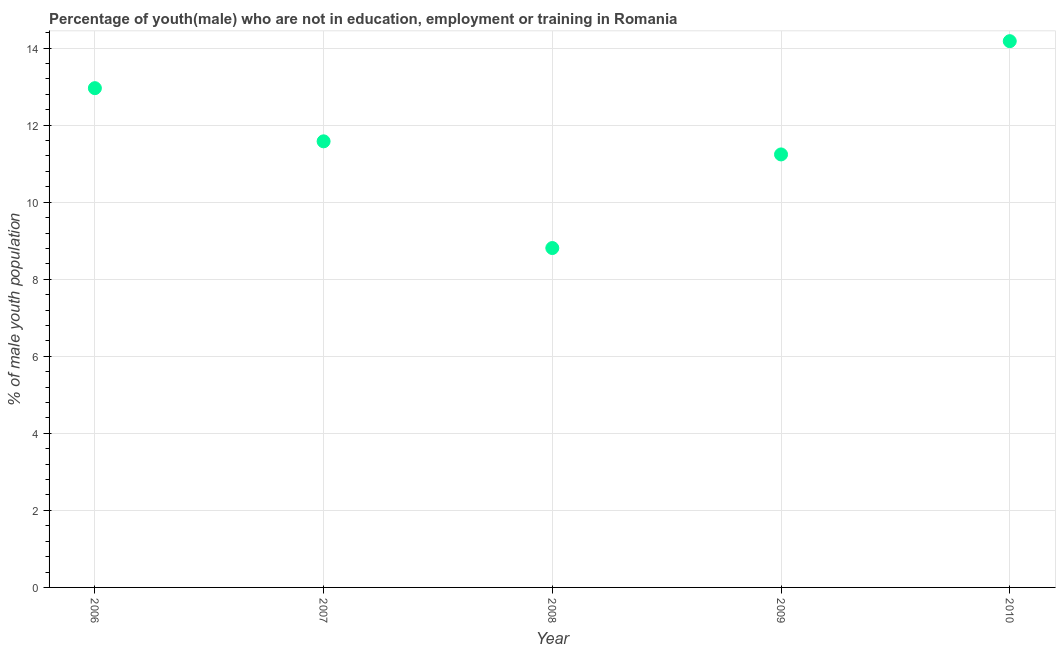What is the unemployed male youth population in 2007?
Your response must be concise. 11.58. Across all years, what is the maximum unemployed male youth population?
Give a very brief answer. 14.18. Across all years, what is the minimum unemployed male youth population?
Your answer should be very brief. 8.81. In which year was the unemployed male youth population maximum?
Make the answer very short. 2010. What is the sum of the unemployed male youth population?
Make the answer very short. 58.77. What is the difference between the unemployed male youth population in 2006 and 2010?
Your answer should be compact. -1.22. What is the average unemployed male youth population per year?
Keep it short and to the point. 11.75. What is the median unemployed male youth population?
Give a very brief answer. 11.58. Do a majority of the years between 2006 and 2008 (inclusive) have unemployed male youth population greater than 0.4 %?
Your answer should be compact. Yes. What is the ratio of the unemployed male youth population in 2006 to that in 2009?
Ensure brevity in your answer.  1.15. Is the difference between the unemployed male youth population in 2007 and 2009 greater than the difference between any two years?
Give a very brief answer. No. What is the difference between the highest and the second highest unemployed male youth population?
Give a very brief answer. 1.22. What is the difference between the highest and the lowest unemployed male youth population?
Your response must be concise. 5.37. In how many years, is the unemployed male youth population greater than the average unemployed male youth population taken over all years?
Make the answer very short. 2. Does the unemployed male youth population monotonically increase over the years?
Give a very brief answer. No. How many dotlines are there?
Make the answer very short. 1. How many years are there in the graph?
Give a very brief answer. 5. What is the difference between two consecutive major ticks on the Y-axis?
Give a very brief answer. 2. Are the values on the major ticks of Y-axis written in scientific E-notation?
Your answer should be very brief. No. Does the graph contain any zero values?
Your response must be concise. No. Does the graph contain grids?
Give a very brief answer. Yes. What is the title of the graph?
Provide a short and direct response. Percentage of youth(male) who are not in education, employment or training in Romania. What is the label or title of the X-axis?
Provide a short and direct response. Year. What is the label or title of the Y-axis?
Offer a terse response. % of male youth population. What is the % of male youth population in 2006?
Give a very brief answer. 12.96. What is the % of male youth population in 2007?
Offer a terse response. 11.58. What is the % of male youth population in 2008?
Offer a very short reply. 8.81. What is the % of male youth population in 2009?
Ensure brevity in your answer.  11.24. What is the % of male youth population in 2010?
Ensure brevity in your answer.  14.18. What is the difference between the % of male youth population in 2006 and 2007?
Offer a very short reply. 1.38. What is the difference between the % of male youth population in 2006 and 2008?
Your answer should be very brief. 4.15. What is the difference between the % of male youth population in 2006 and 2009?
Make the answer very short. 1.72. What is the difference between the % of male youth population in 2006 and 2010?
Ensure brevity in your answer.  -1.22. What is the difference between the % of male youth population in 2007 and 2008?
Give a very brief answer. 2.77. What is the difference between the % of male youth population in 2007 and 2009?
Your answer should be compact. 0.34. What is the difference between the % of male youth population in 2008 and 2009?
Your response must be concise. -2.43. What is the difference between the % of male youth population in 2008 and 2010?
Your response must be concise. -5.37. What is the difference between the % of male youth population in 2009 and 2010?
Provide a succinct answer. -2.94. What is the ratio of the % of male youth population in 2006 to that in 2007?
Offer a very short reply. 1.12. What is the ratio of the % of male youth population in 2006 to that in 2008?
Offer a terse response. 1.47. What is the ratio of the % of male youth population in 2006 to that in 2009?
Make the answer very short. 1.15. What is the ratio of the % of male youth population in 2006 to that in 2010?
Your answer should be very brief. 0.91. What is the ratio of the % of male youth population in 2007 to that in 2008?
Offer a terse response. 1.31. What is the ratio of the % of male youth population in 2007 to that in 2009?
Keep it short and to the point. 1.03. What is the ratio of the % of male youth population in 2007 to that in 2010?
Your answer should be compact. 0.82. What is the ratio of the % of male youth population in 2008 to that in 2009?
Keep it short and to the point. 0.78. What is the ratio of the % of male youth population in 2008 to that in 2010?
Offer a very short reply. 0.62. What is the ratio of the % of male youth population in 2009 to that in 2010?
Your answer should be very brief. 0.79. 